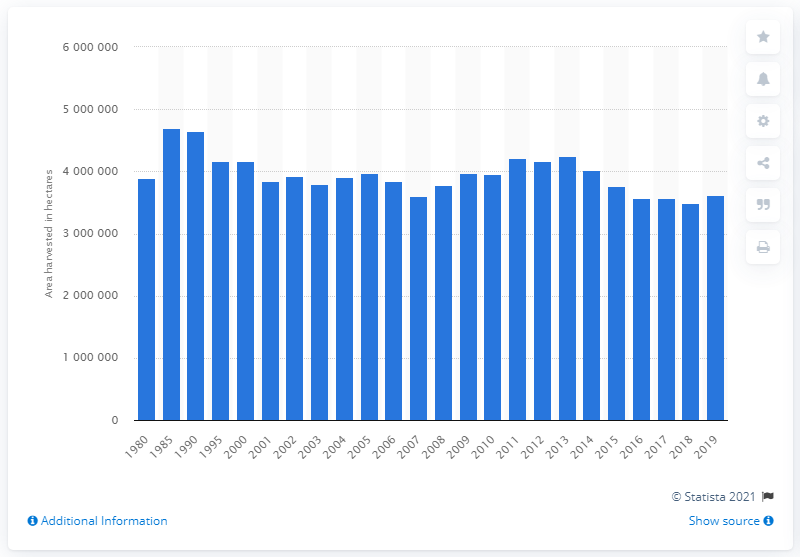Mention a couple of crucial points in this snapshot. In 2018, the total area of harvested tobacco was approximately 348,381.7 hectares. The total area of harvested tobacco in 2019 was 361,911.8 hectares. 